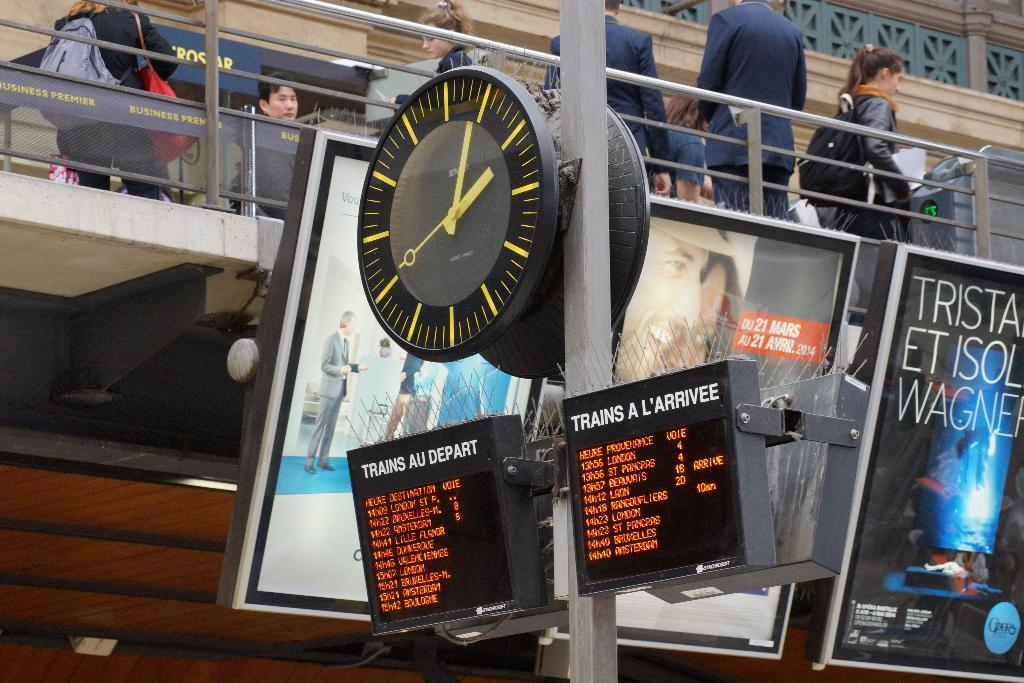<image>
Give a short and clear explanation of the subsequent image. Under a clock are two boards, one reads "trains au depart" and the other "trains a l'arrivee." 